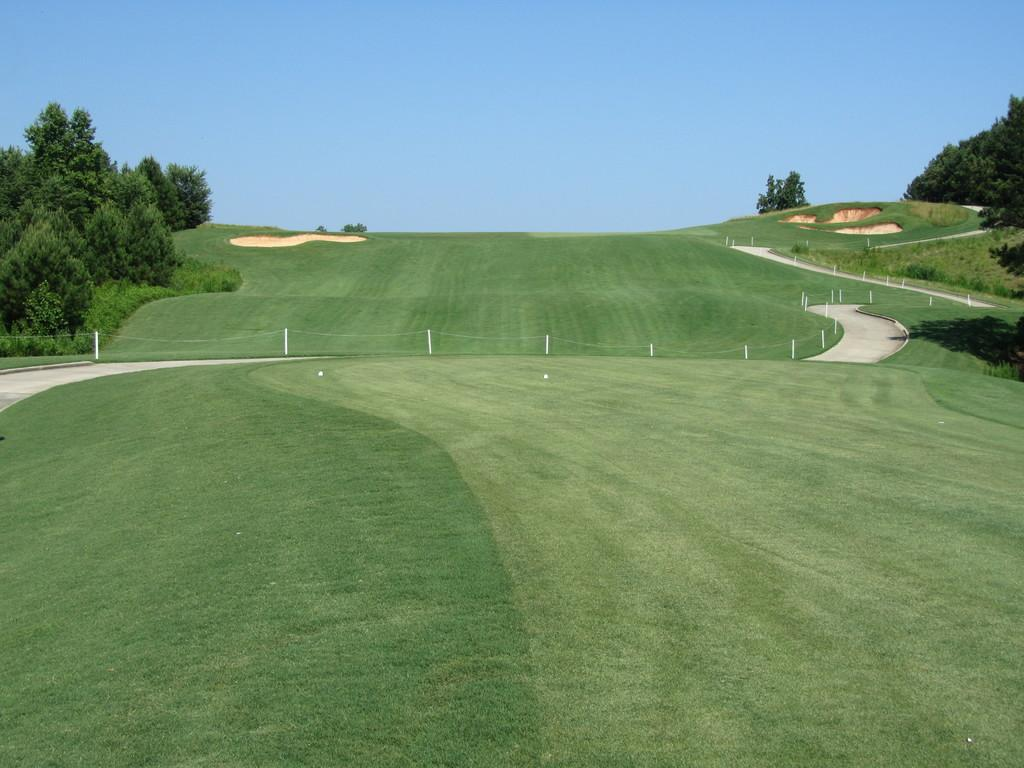What type of vegetation can be seen in the image? There are trees in the image. What else is present in the image besides trees? There is fencing and grass in the image. What can be seen in the background of the image? The sky is visible in the image. How many bars of soap can be seen in the image? There is no soap present in the image. Are there any crying individuals in the image? There is no indication of anyone crying in the image. 